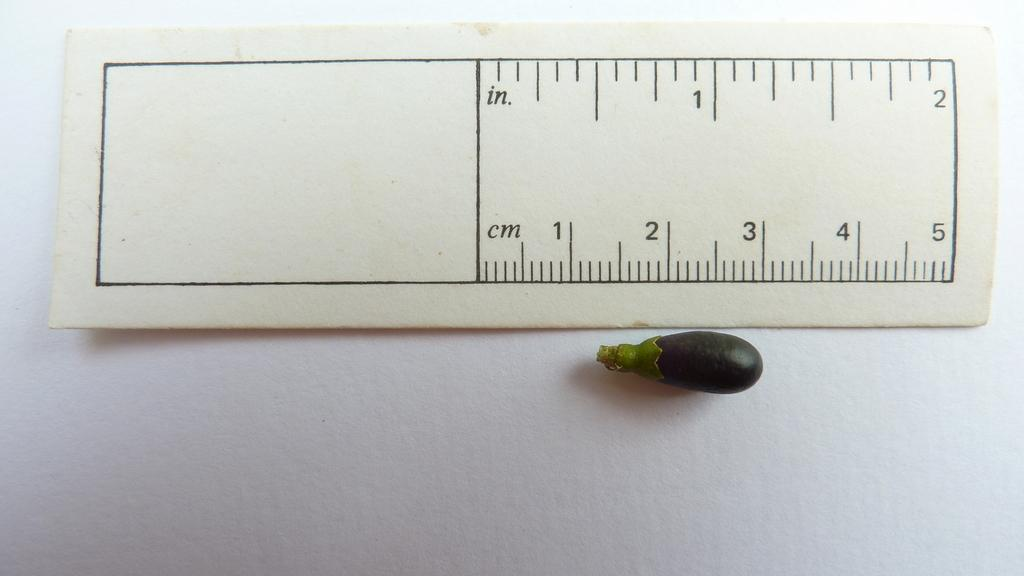<image>
Present a compact description of the photo's key features. A measurement of a small eggplant, showing it as under 2 cm. 